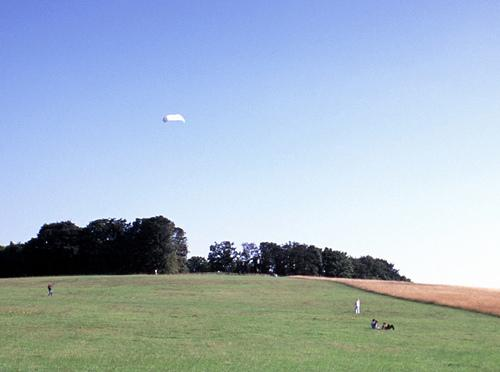Describe the elements that make the image visually appealing. The contrasting colors of a cloudless blue sky, lush green grass, and the white kite soaring high create a charming visual. Narrate the scene in a poetic manner. Underneath the vast expanse of azure sky, people gather on nature's verdant carpet, as the ethereal kite dances with the breeze. Write a sentence describing the overall atmosphere of the image. The image exudes a sense of peace and tranquility, with people enjoying the outdoors under an expansive sky. Mention the greenery you see in the image and give some context about it. The image features a field of lush green grass, with dark green trees in the distance forming the edge of the field. Identify the element in the air and describe its appearance. A white kite with a bright white streak is flying high in the clear blue sky without any clouds. What are the people engaged in, in the image? People are sitting and standing on the green grass, while someone is flying a white kite in the clear sky. Write a one-liner describing the main focus of the image. People enjoying nature while flying a bright kite under a blue, cloudless sky. What is the sky like in the image? Be descriptive. The sky is a spectacular shade of blue, without any clouds, providing the perfect backdrop for the kite flying in the air. Briefly describe the dominant colors and their location in the image. The image showcases bright blue skies, vibrant green grass, and a white kite in the air. Describe the setting of the image and its atmosphere. The image depicts a beautiful, serene scene of people enjoying a day on the grass under a vast blue sky. 